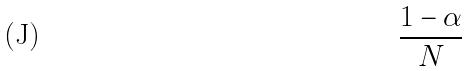<formula> <loc_0><loc_0><loc_500><loc_500>\frac { 1 - \alpha } { N }</formula> 